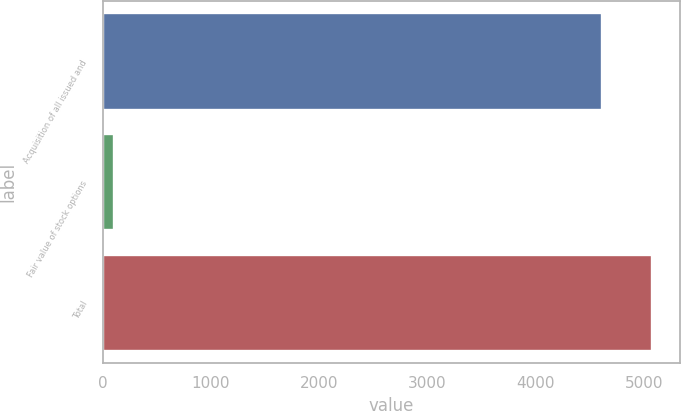<chart> <loc_0><loc_0><loc_500><loc_500><bar_chart><fcel>Acquisition of all issued and<fcel>Fair value of stock options<fcel>Total<nl><fcel>4612<fcel>102<fcel>5073.2<nl></chart> 